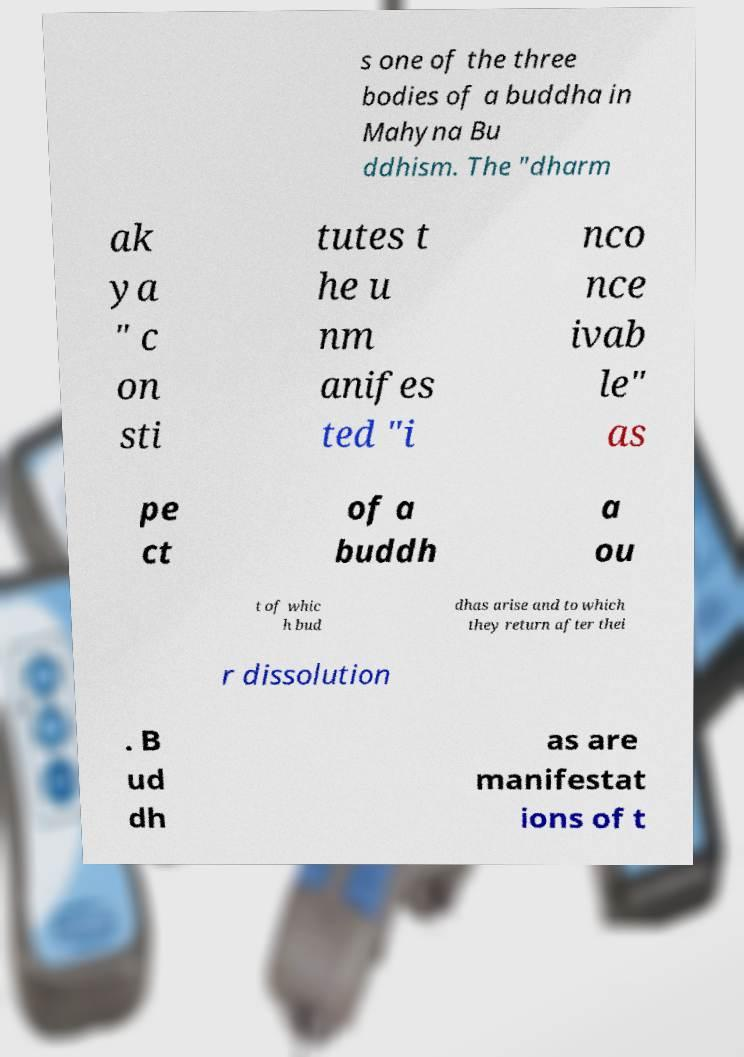Could you extract and type out the text from this image? s one of the three bodies of a buddha in Mahyna Bu ddhism. The "dharm ak ya " c on sti tutes t he u nm anifes ted "i nco nce ivab le" as pe ct of a buddh a ou t of whic h bud dhas arise and to which they return after thei r dissolution . B ud dh as are manifestat ions of t 